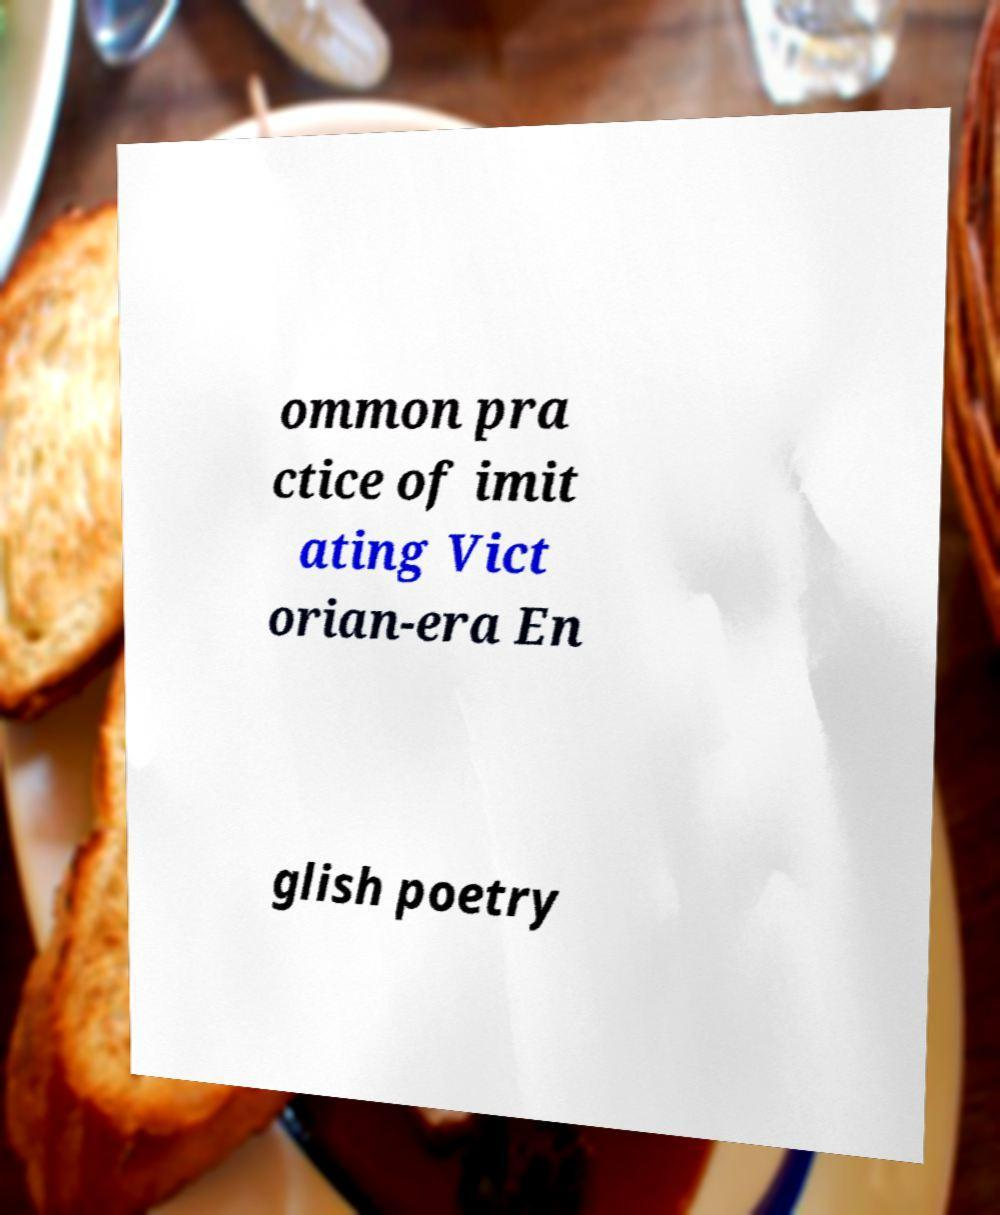Could you assist in decoding the text presented in this image and type it out clearly? ommon pra ctice of imit ating Vict orian-era En glish poetry 